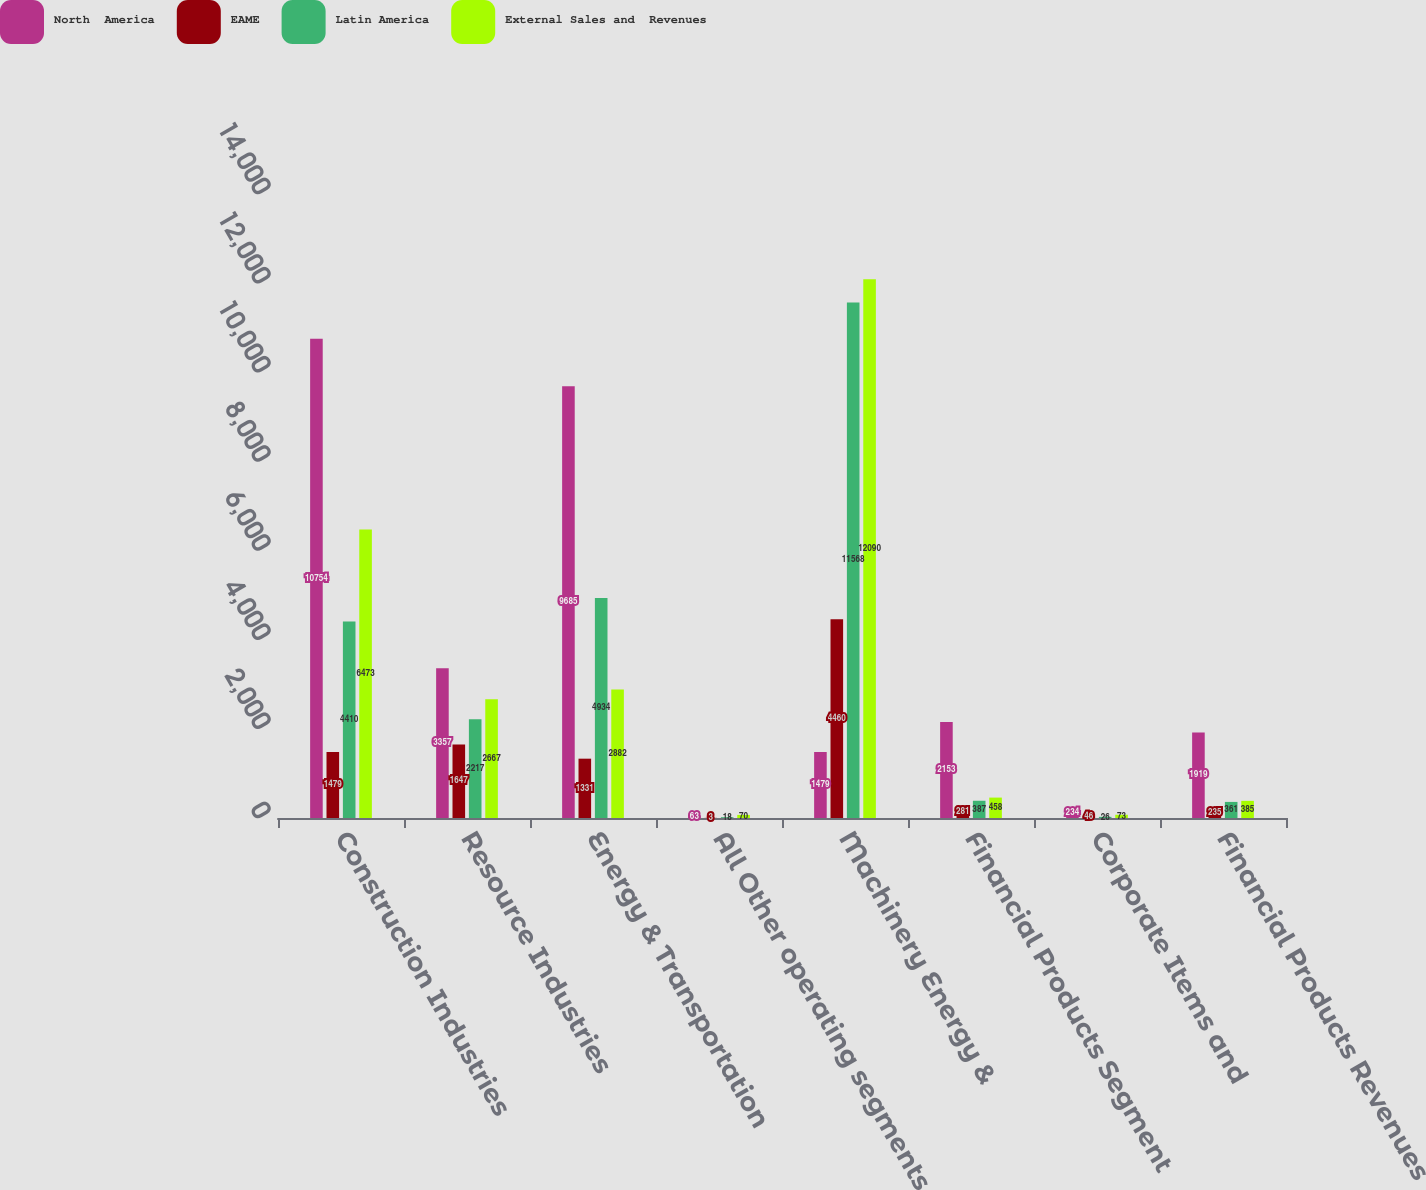Convert chart to OTSL. <chart><loc_0><loc_0><loc_500><loc_500><stacked_bar_chart><ecel><fcel>Construction Industries<fcel>Resource Industries<fcel>Energy & Transportation<fcel>All Other operating segments<fcel>Machinery Energy &<fcel>Financial Products Segment<fcel>Corporate Items and<fcel>Financial Products Revenues<nl><fcel>North  America<fcel>10754<fcel>3357<fcel>9685<fcel>63<fcel>1479<fcel>2153<fcel>234<fcel>1919<nl><fcel>EAME<fcel>1479<fcel>1647<fcel>1331<fcel>3<fcel>4460<fcel>281<fcel>46<fcel>235<nl><fcel>Latin America<fcel>4410<fcel>2217<fcel>4934<fcel>18<fcel>11568<fcel>387<fcel>26<fcel>361<nl><fcel>External Sales and  Revenues<fcel>6473<fcel>2667<fcel>2882<fcel>70<fcel>12090<fcel>458<fcel>73<fcel>385<nl></chart> 